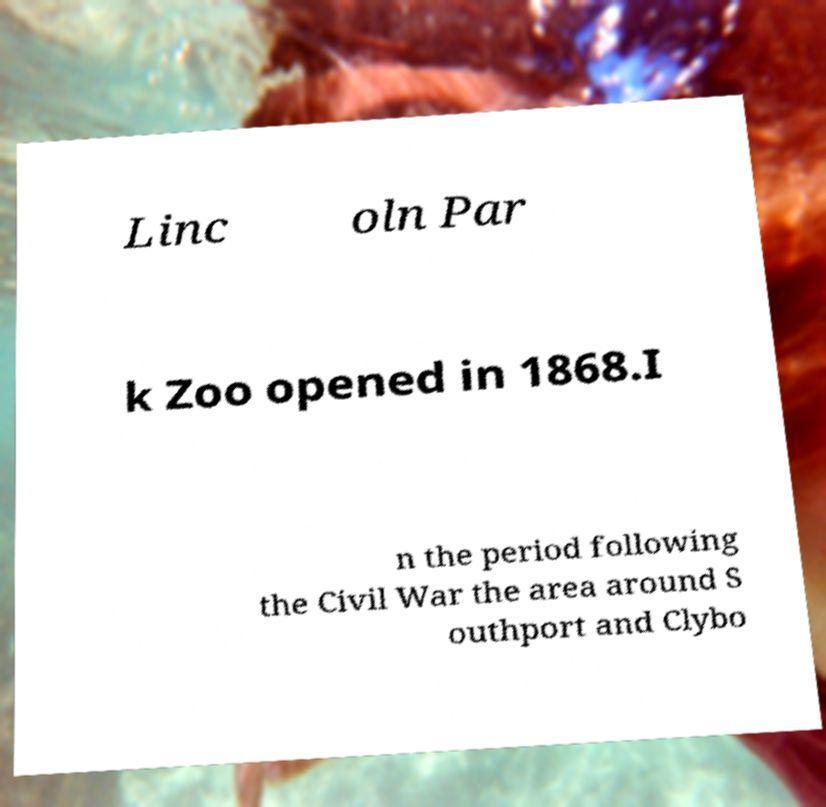Can you accurately transcribe the text from the provided image for me? Linc oln Par k Zoo opened in 1868.I n the period following the Civil War the area around S outhport and Clybo 